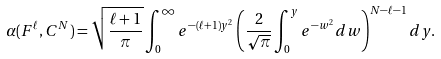<formula> <loc_0><loc_0><loc_500><loc_500>\alpha ( F ^ { \ell } , C ^ { N } ) = \sqrt { \frac { \ell + 1 } { \pi } } \int _ { 0 } ^ { \infty } e ^ { - ( \ell + 1 ) y ^ { 2 } } \left ( \frac { 2 } { \sqrt { \pi } } \int _ { 0 } ^ { y } e ^ { - w ^ { 2 } } d w \right ) ^ { N - \ell - 1 } d y .</formula> 